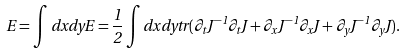Convert formula to latex. <formula><loc_0><loc_0><loc_500><loc_500>E = \int d x d y E = \frac { 1 } { 2 } \int d x d y t r ( \partial _ { t } J ^ { - 1 } \partial _ { t } J + \partial _ { x } J ^ { - 1 } \partial _ { x } J + \partial _ { y } J ^ { - 1 } \partial _ { y } J ) .</formula> 